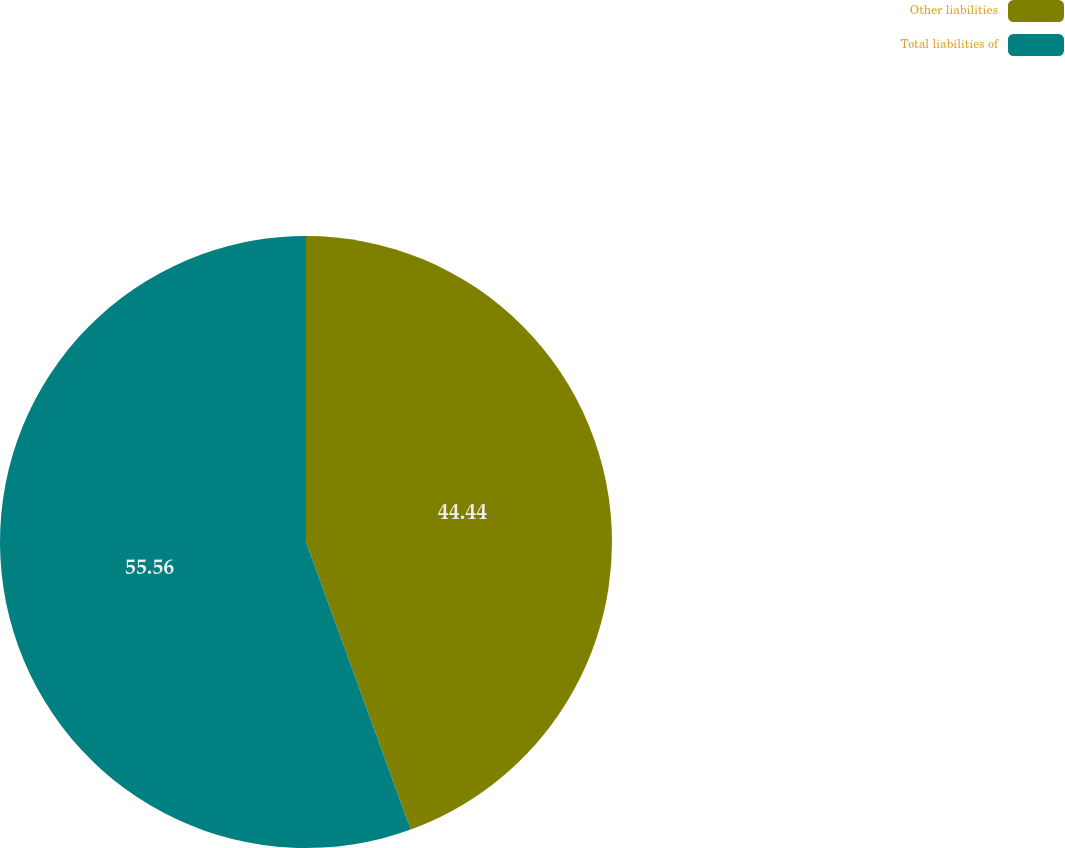Convert chart. <chart><loc_0><loc_0><loc_500><loc_500><pie_chart><fcel>Other liabilities<fcel>Total liabilities of<nl><fcel>44.44%<fcel>55.56%<nl></chart> 